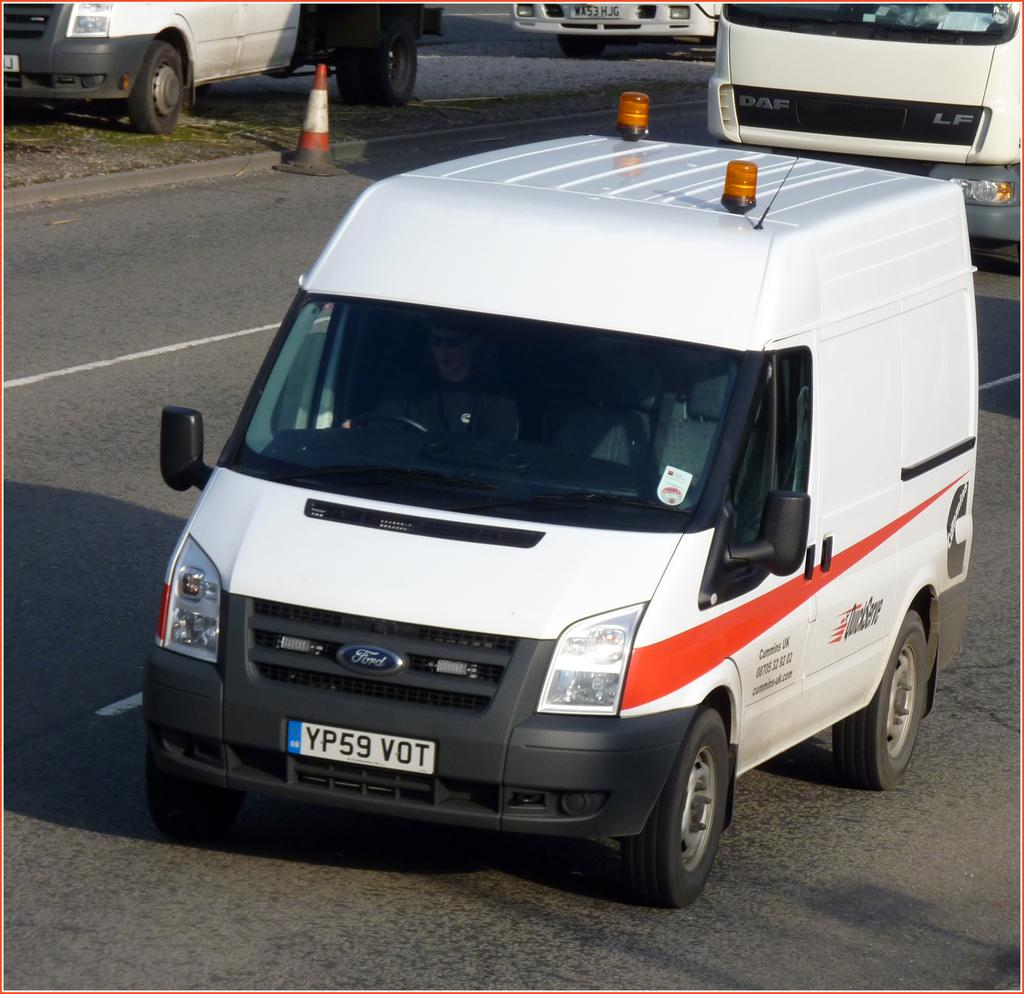<image>
Render a clear and concise summary of the photo. a white van in a parking lot with license plate YP59 VOT 